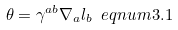<formula> <loc_0><loc_0><loc_500><loc_500>\theta = \gamma ^ { a b } \nabla _ { a } l _ { b } \ e q n u m { 3 . 1 }</formula> 